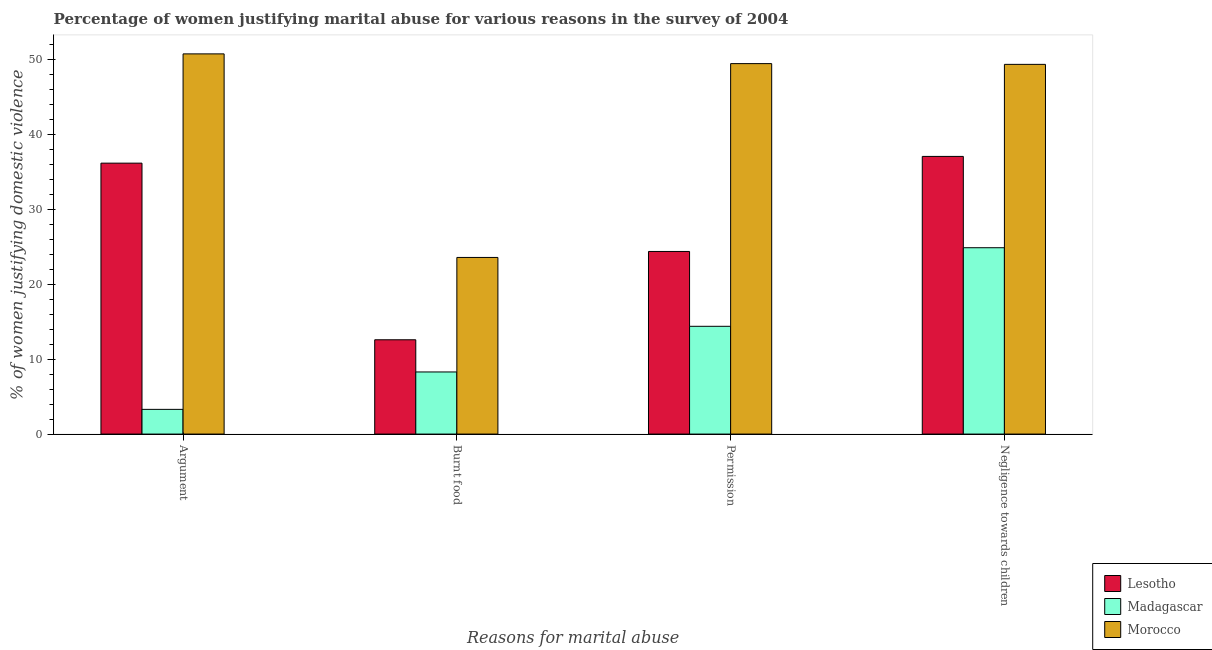How many different coloured bars are there?
Provide a succinct answer. 3. Are the number of bars per tick equal to the number of legend labels?
Make the answer very short. Yes. Are the number of bars on each tick of the X-axis equal?
Ensure brevity in your answer.  Yes. How many bars are there on the 4th tick from the left?
Provide a succinct answer. 3. What is the label of the 3rd group of bars from the left?
Ensure brevity in your answer.  Permission. What is the percentage of women justifying abuse for showing negligence towards children in Morocco?
Provide a short and direct response. 49.4. Across all countries, what is the maximum percentage of women justifying abuse in the case of an argument?
Give a very brief answer. 50.8. Across all countries, what is the minimum percentage of women justifying abuse for showing negligence towards children?
Your answer should be compact. 24.9. In which country was the percentage of women justifying abuse for showing negligence towards children maximum?
Your answer should be very brief. Morocco. In which country was the percentage of women justifying abuse for burning food minimum?
Provide a succinct answer. Madagascar. What is the total percentage of women justifying abuse in the case of an argument in the graph?
Keep it short and to the point. 90.3. What is the difference between the percentage of women justifying abuse for burning food in Morocco and that in Lesotho?
Give a very brief answer. 11. What is the difference between the percentage of women justifying abuse in the case of an argument in Lesotho and the percentage of women justifying abuse for burning food in Madagascar?
Make the answer very short. 27.9. What is the average percentage of women justifying abuse for burning food per country?
Keep it short and to the point. 14.83. What is the difference between the percentage of women justifying abuse for burning food and percentage of women justifying abuse for going without permission in Madagascar?
Your response must be concise. -6.1. What is the ratio of the percentage of women justifying abuse in the case of an argument in Morocco to that in Madagascar?
Provide a succinct answer. 15.39. Is the percentage of women justifying abuse for showing negligence towards children in Madagascar less than that in Morocco?
Offer a terse response. Yes. Is the difference between the percentage of women justifying abuse in the case of an argument in Lesotho and Morocco greater than the difference between the percentage of women justifying abuse for showing negligence towards children in Lesotho and Morocco?
Give a very brief answer. No. What is the difference between the highest and the second highest percentage of women justifying abuse in the case of an argument?
Your answer should be very brief. 14.6. What is the difference between the highest and the lowest percentage of women justifying abuse for going without permission?
Ensure brevity in your answer.  35.1. In how many countries, is the percentage of women justifying abuse in the case of an argument greater than the average percentage of women justifying abuse in the case of an argument taken over all countries?
Provide a short and direct response. 2. Is it the case that in every country, the sum of the percentage of women justifying abuse for showing negligence towards children and percentage of women justifying abuse for burning food is greater than the sum of percentage of women justifying abuse for going without permission and percentage of women justifying abuse in the case of an argument?
Your answer should be compact. No. What does the 3rd bar from the left in Negligence towards children represents?
Give a very brief answer. Morocco. What does the 1st bar from the right in Negligence towards children represents?
Provide a short and direct response. Morocco. Is it the case that in every country, the sum of the percentage of women justifying abuse in the case of an argument and percentage of women justifying abuse for burning food is greater than the percentage of women justifying abuse for going without permission?
Offer a terse response. No. Are all the bars in the graph horizontal?
Make the answer very short. No. How many countries are there in the graph?
Ensure brevity in your answer.  3. What is the difference between two consecutive major ticks on the Y-axis?
Keep it short and to the point. 10. Does the graph contain any zero values?
Ensure brevity in your answer.  No. Where does the legend appear in the graph?
Offer a very short reply. Bottom right. How many legend labels are there?
Your response must be concise. 3. What is the title of the graph?
Keep it short and to the point. Percentage of women justifying marital abuse for various reasons in the survey of 2004. What is the label or title of the X-axis?
Your answer should be compact. Reasons for marital abuse. What is the label or title of the Y-axis?
Your response must be concise. % of women justifying domestic violence. What is the % of women justifying domestic violence in Lesotho in Argument?
Ensure brevity in your answer.  36.2. What is the % of women justifying domestic violence in Madagascar in Argument?
Ensure brevity in your answer.  3.3. What is the % of women justifying domestic violence in Morocco in Argument?
Your answer should be compact. 50.8. What is the % of women justifying domestic violence in Lesotho in Burnt food?
Offer a very short reply. 12.6. What is the % of women justifying domestic violence in Morocco in Burnt food?
Make the answer very short. 23.6. What is the % of women justifying domestic violence of Lesotho in Permission?
Keep it short and to the point. 24.4. What is the % of women justifying domestic violence in Madagascar in Permission?
Keep it short and to the point. 14.4. What is the % of women justifying domestic violence of Morocco in Permission?
Your response must be concise. 49.5. What is the % of women justifying domestic violence in Lesotho in Negligence towards children?
Offer a terse response. 37.1. What is the % of women justifying domestic violence in Madagascar in Negligence towards children?
Offer a terse response. 24.9. What is the % of women justifying domestic violence of Morocco in Negligence towards children?
Provide a short and direct response. 49.4. Across all Reasons for marital abuse, what is the maximum % of women justifying domestic violence in Lesotho?
Offer a terse response. 37.1. Across all Reasons for marital abuse, what is the maximum % of women justifying domestic violence in Madagascar?
Give a very brief answer. 24.9. Across all Reasons for marital abuse, what is the maximum % of women justifying domestic violence of Morocco?
Your answer should be very brief. 50.8. Across all Reasons for marital abuse, what is the minimum % of women justifying domestic violence of Lesotho?
Provide a short and direct response. 12.6. Across all Reasons for marital abuse, what is the minimum % of women justifying domestic violence in Morocco?
Give a very brief answer. 23.6. What is the total % of women justifying domestic violence in Lesotho in the graph?
Ensure brevity in your answer.  110.3. What is the total % of women justifying domestic violence of Madagascar in the graph?
Your response must be concise. 50.9. What is the total % of women justifying domestic violence of Morocco in the graph?
Give a very brief answer. 173.3. What is the difference between the % of women justifying domestic violence of Lesotho in Argument and that in Burnt food?
Ensure brevity in your answer.  23.6. What is the difference between the % of women justifying domestic violence in Morocco in Argument and that in Burnt food?
Keep it short and to the point. 27.2. What is the difference between the % of women justifying domestic violence in Madagascar in Argument and that in Permission?
Your response must be concise. -11.1. What is the difference between the % of women justifying domestic violence in Lesotho in Argument and that in Negligence towards children?
Provide a succinct answer. -0.9. What is the difference between the % of women justifying domestic violence of Madagascar in Argument and that in Negligence towards children?
Provide a short and direct response. -21.6. What is the difference between the % of women justifying domestic violence in Morocco in Argument and that in Negligence towards children?
Offer a terse response. 1.4. What is the difference between the % of women justifying domestic violence of Lesotho in Burnt food and that in Permission?
Offer a terse response. -11.8. What is the difference between the % of women justifying domestic violence in Madagascar in Burnt food and that in Permission?
Your answer should be very brief. -6.1. What is the difference between the % of women justifying domestic violence in Morocco in Burnt food and that in Permission?
Keep it short and to the point. -25.9. What is the difference between the % of women justifying domestic violence in Lesotho in Burnt food and that in Negligence towards children?
Ensure brevity in your answer.  -24.5. What is the difference between the % of women justifying domestic violence in Madagascar in Burnt food and that in Negligence towards children?
Offer a terse response. -16.6. What is the difference between the % of women justifying domestic violence of Morocco in Burnt food and that in Negligence towards children?
Give a very brief answer. -25.8. What is the difference between the % of women justifying domestic violence in Madagascar in Permission and that in Negligence towards children?
Keep it short and to the point. -10.5. What is the difference between the % of women justifying domestic violence in Lesotho in Argument and the % of women justifying domestic violence in Madagascar in Burnt food?
Your response must be concise. 27.9. What is the difference between the % of women justifying domestic violence in Madagascar in Argument and the % of women justifying domestic violence in Morocco in Burnt food?
Offer a very short reply. -20.3. What is the difference between the % of women justifying domestic violence in Lesotho in Argument and the % of women justifying domestic violence in Madagascar in Permission?
Offer a terse response. 21.8. What is the difference between the % of women justifying domestic violence of Lesotho in Argument and the % of women justifying domestic violence of Morocco in Permission?
Keep it short and to the point. -13.3. What is the difference between the % of women justifying domestic violence in Madagascar in Argument and the % of women justifying domestic violence in Morocco in Permission?
Offer a terse response. -46.2. What is the difference between the % of women justifying domestic violence in Lesotho in Argument and the % of women justifying domestic violence in Madagascar in Negligence towards children?
Your response must be concise. 11.3. What is the difference between the % of women justifying domestic violence in Lesotho in Argument and the % of women justifying domestic violence in Morocco in Negligence towards children?
Provide a succinct answer. -13.2. What is the difference between the % of women justifying domestic violence of Madagascar in Argument and the % of women justifying domestic violence of Morocco in Negligence towards children?
Give a very brief answer. -46.1. What is the difference between the % of women justifying domestic violence in Lesotho in Burnt food and the % of women justifying domestic violence in Madagascar in Permission?
Your answer should be compact. -1.8. What is the difference between the % of women justifying domestic violence of Lesotho in Burnt food and the % of women justifying domestic violence of Morocco in Permission?
Offer a terse response. -36.9. What is the difference between the % of women justifying domestic violence of Madagascar in Burnt food and the % of women justifying domestic violence of Morocco in Permission?
Offer a terse response. -41.2. What is the difference between the % of women justifying domestic violence of Lesotho in Burnt food and the % of women justifying domestic violence of Morocco in Negligence towards children?
Your answer should be very brief. -36.8. What is the difference between the % of women justifying domestic violence in Madagascar in Burnt food and the % of women justifying domestic violence in Morocco in Negligence towards children?
Give a very brief answer. -41.1. What is the difference between the % of women justifying domestic violence of Madagascar in Permission and the % of women justifying domestic violence of Morocco in Negligence towards children?
Make the answer very short. -35. What is the average % of women justifying domestic violence of Lesotho per Reasons for marital abuse?
Your answer should be compact. 27.57. What is the average % of women justifying domestic violence of Madagascar per Reasons for marital abuse?
Ensure brevity in your answer.  12.72. What is the average % of women justifying domestic violence of Morocco per Reasons for marital abuse?
Your answer should be compact. 43.33. What is the difference between the % of women justifying domestic violence in Lesotho and % of women justifying domestic violence in Madagascar in Argument?
Provide a succinct answer. 32.9. What is the difference between the % of women justifying domestic violence of Lesotho and % of women justifying domestic violence of Morocco in Argument?
Ensure brevity in your answer.  -14.6. What is the difference between the % of women justifying domestic violence of Madagascar and % of women justifying domestic violence of Morocco in Argument?
Ensure brevity in your answer.  -47.5. What is the difference between the % of women justifying domestic violence in Lesotho and % of women justifying domestic violence in Madagascar in Burnt food?
Provide a short and direct response. 4.3. What is the difference between the % of women justifying domestic violence in Lesotho and % of women justifying domestic violence in Morocco in Burnt food?
Provide a succinct answer. -11. What is the difference between the % of women justifying domestic violence of Madagascar and % of women justifying domestic violence of Morocco in Burnt food?
Ensure brevity in your answer.  -15.3. What is the difference between the % of women justifying domestic violence in Lesotho and % of women justifying domestic violence in Morocco in Permission?
Provide a succinct answer. -25.1. What is the difference between the % of women justifying domestic violence in Madagascar and % of women justifying domestic violence in Morocco in Permission?
Ensure brevity in your answer.  -35.1. What is the difference between the % of women justifying domestic violence of Lesotho and % of women justifying domestic violence of Madagascar in Negligence towards children?
Your answer should be compact. 12.2. What is the difference between the % of women justifying domestic violence of Madagascar and % of women justifying domestic violence of Morocco in Negligence towards children?
Provide a short and direct response. -24.5. What is the ratio of the % of women justifying domestic violence in Lesotho in Argument to that in Burnt food?
Offer a very short reply. 2.87. What is the ratio of the % of women justifying domestic violence in Madagascar in Argument to that in Burnt food?
Provide a short and direct response. 0.4. What is the ratio of the % of women justifying domestic violence of Morocco in Argument to that in Burnt food?
Offer a terse response. 2.15. What is the ratio of the % of women justifying domestic violence of Lesotho in Argument to that in Permission?
Your answer should be compact. 1.48. What is the ratio of the % of women justifying domestic violence in Madagascar in Argument to that in Permission?
Ensure brevity in your answer.  0.23. What is the ratio of the % of women justifying domestic violence in Morocco in Argument to that in Permission?
Your response must be concise. 1.03. What is the ratio of the % of women justifying domestic violence of Lesotho in Argument to that in Negligence towards children?
Provide a succinct answer. 0.98. What is the ratio of the % of women justifying domestic violence of Madagascar in Argument to that in Negligence towards children?
Offer a terse response. 0.13. What is the ratio of the % of women justifying domestic violence of Morocco in Argument to that in Negligence towards children?
Offer a very short reply. 1.03. What is the ratio of the % of women justifying domestic violence of Lesotho in Burnt food to that in Permission?
Make the answer very short. 0.52. What is the ratio of the % of women justifying domestic violence of Madagascar in Burnt food to that in Permission?
Provide a short and direct response. 0.58. What is the ratio of the % of women justifying domestic violence of Morocco in Burnt food to that in Permission?
Your answer should be compact. 0.48. What is the ratio of the % of women justifying domestic violence in Lesotho in Burnt food to that in Negligence towards children?
Offer a terse response. 0.34. What is the ratio of the % of women justifying domestic violence of Madagascar in Burnt food to that in Negligence towards children?
Offer a terse response. 0.33. What is the ratio of the % of women justifying domestic violence of Morocco in Burnt food to that in Negligence towards children?
Your response must be concise. 0.48. What is the ratio of the % of women justifying domestic violence of Lesotho in Permission to that in Negligence towards children?
Your response must be concise. 0.66. What is the ratio of the % of women justifying domestic violence of Madagascar in Permission to that in Negligence towards children?
Give a very brief answer. 0.58. What is the ratio of the % of women justifying domestic violence of Morocco in Permission to that in Negligence towards children?
Provide a short and direct response. 1. What is the difference between the highest and the second highest % of women justifying domestic violence of Madagascar?
Offer a terse response. 10.5. What is the difference between the highest and the second highest % of women justifying domestic violence of Morocco?
Your answer should be compact. 1.3. What is the difference between the highest and the lowest % of women justifying domestic violence in Lesotho?
Your answer should be very brief. 24.5. What is the difference between the highest and the lowest % of women justifying domestic violence of Madagascar?
Make the answer very short. 21.6. What is the difference between the highest and the lowest % of women justifying domestic violence in Morocco?
Offer a very short reply. 27.2. 